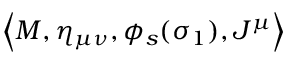<formula> <loc_0><loc_0><loc_500><loc_500>\left < M , \eta _ { \mu \nu } , \phi _ { s } ( \sigma _ { 1 } ) , J ^ { \mu } \right ></formula> 